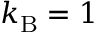<formula> <loc_0><loc_0><loc_500><loc_500>k _ { B } = 1</formula> 